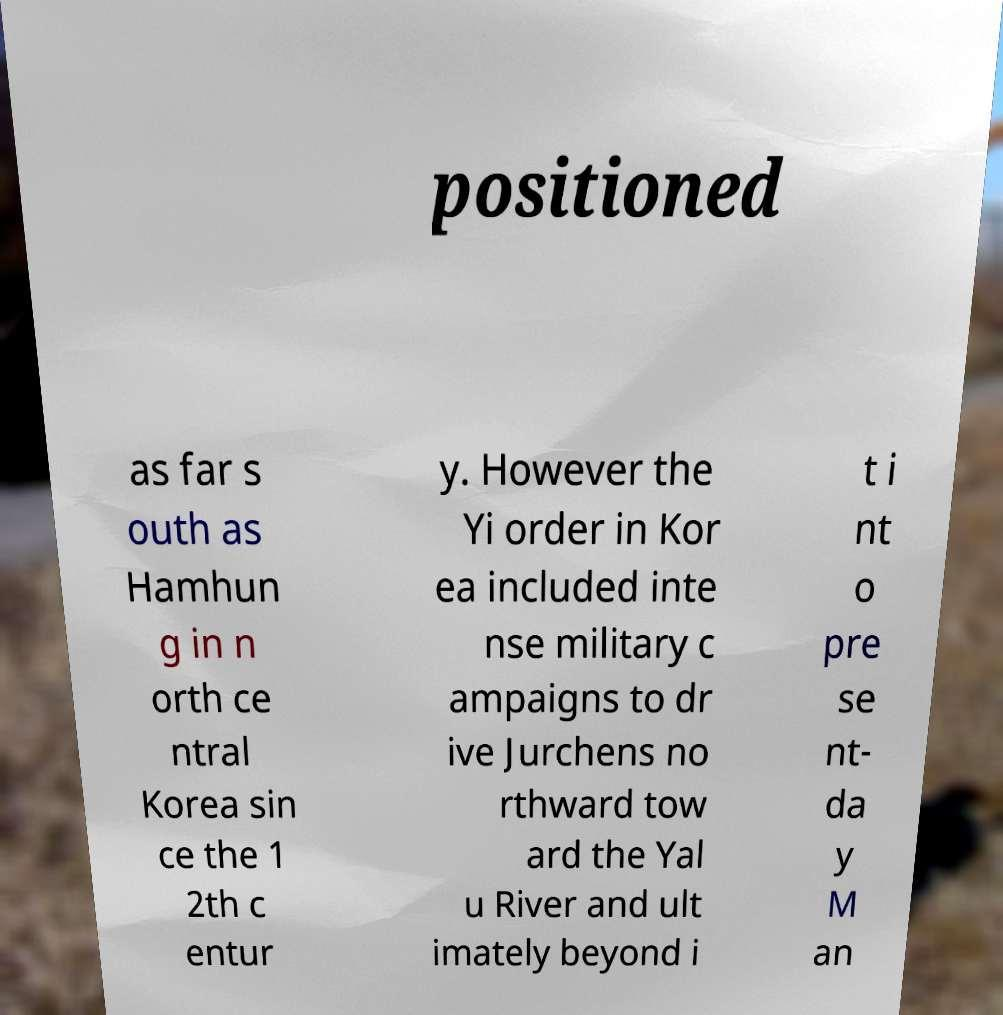What messages or text are displayed in this image? I need them in a readable, typed format. positioned as far s outh as Hamhun g in n orth ce ntral Korea sin ce the 1 2th c entur y. However the Yi order in Kor ea included inte nse military c ampaigns to dr ive Jurchens no rthward tow ard the Yal u River and ult imately beyond i t i nt o pre se nt- da y M an 